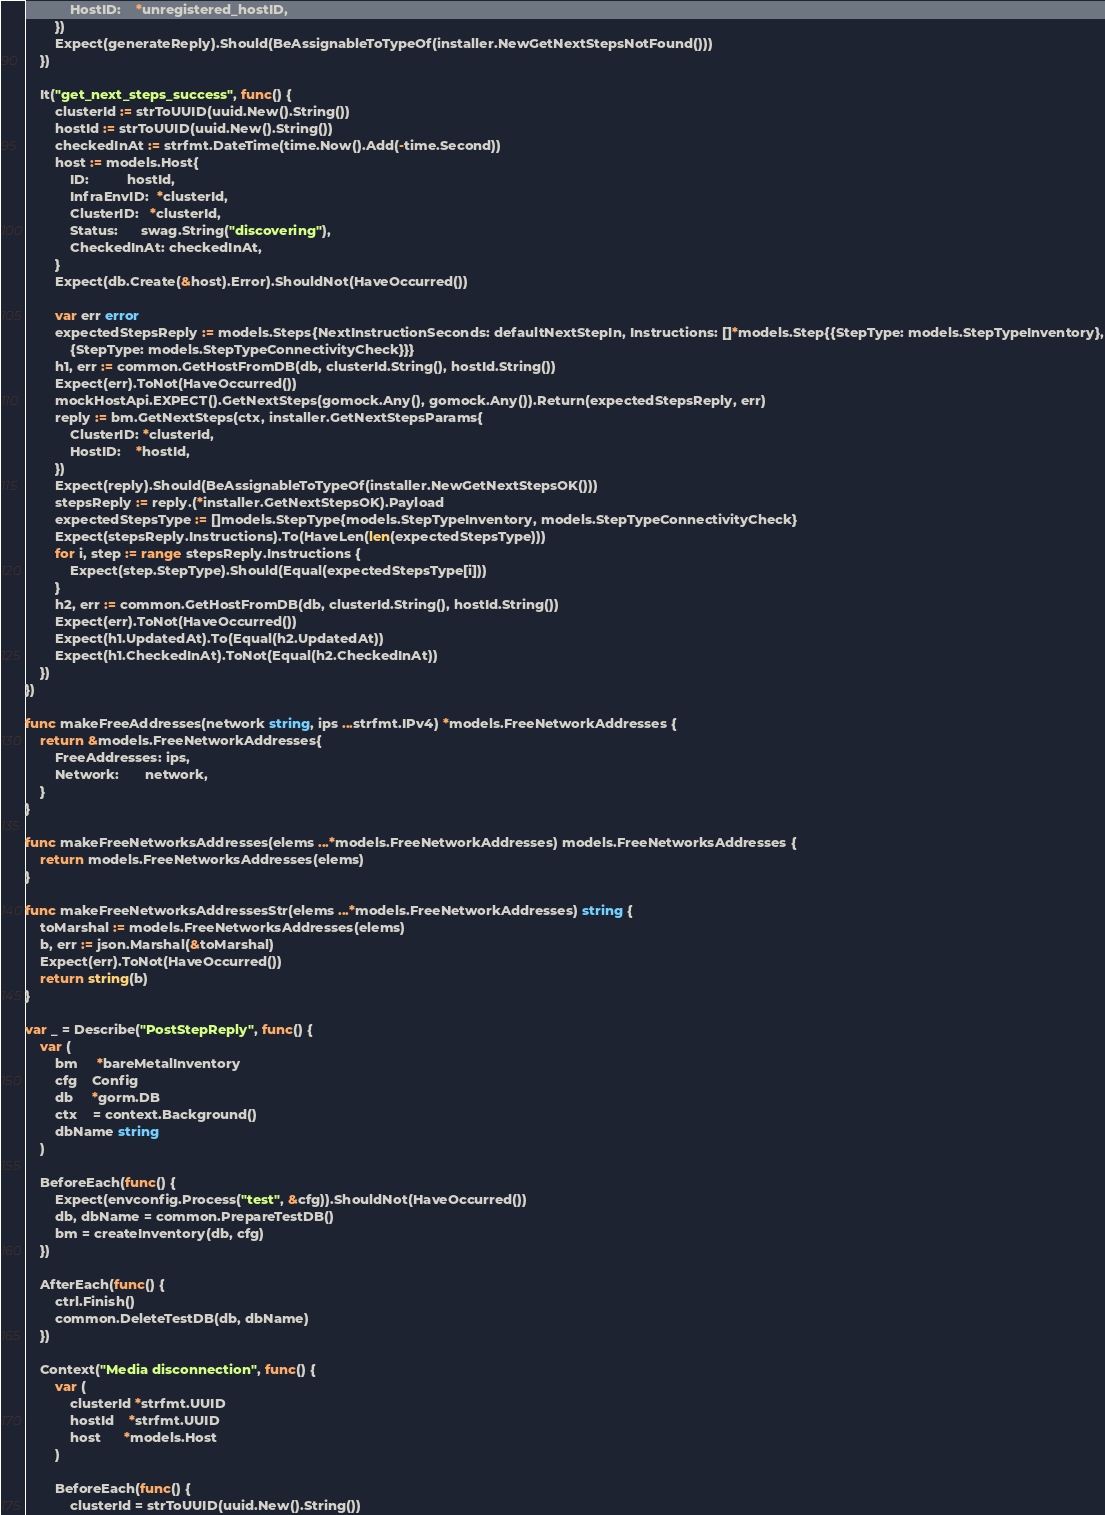<code> <loc_0><loc_0><loc_500><loc_500><_Go_>			HostID:    *unregistered_hostID,
		})
		Expect(generateReply).Should(BeAssignableToTypeOf(installer.NewGetNextStepsNotFound()))
	})

	It("get_next_steps_success", func() {
		clusterId := strToUUID(uuid.New().String())
		hostId := strToUUID(uuid.New().String())
		checkedInAt := strfmt.DateTime(time.Now().Add(-time.Second))
		host := models.Host{
			ID:          hostId,
			InfraEnvID:  *clusterId,
			ClusterID:   *clusterId,
			Status:      swag.String("discovering"),
			CheckedInAt: checkedInAt,
		}
		Expect(db.Create(&host).Error).ShouldNot(HaveOccurred())

		var err error
		expectedStepsReply := models.Steps{NextInstructionSeconds: defaultNextStepIn, Instructions: []*models.Step{{StepType: models.StepTypeInventory},
			{StepType: models.StepTypeConnectivityCheck}}}
		h1, err := common.GetHostFromDB(db, clusterId.String(), hostId.String())
		Expect(err).ToNot(HaveOccurred())
		mockHostApi.EXPECT().GetNextSteps(gomock.Any(), gomock.Any()).Return(expectedStepsReply, err)
		reply := bm.GetNextSteps(ctx, installer.GetNextStepsParams{
			ClusterID: *clusterId,
			HostID:    *hostId,
		})
		Expect(reply).Should(BeAssignableToTypeOf(installer.NewGetNextStepsOK()))
		stepsReply := reply.(*installer.GetNextStepsOK).Payload
		expectedStepsType := []models.StepType{models.StepTypeInventory, models.StepTypeConnectivityCheck}
		Expect(stepsReply.Instructions).To(HaveLen(len(expectedStepsType)))
		for i, step := range stepsReply.Instructions {
			Expect(step.StepType).Should(Equal(expectedStepsType[i]))
		}
		h2, err := common.GetHostFromDB(db, clusterId.String(), hostId.String())
		Expect(err).ToNot(HaveOccurred())
		Expect(h1.UpdatedAt).To(Equal(h2.UpdatedAt))
		Expect(h1.CheckedInAt).ToNot(Equal(h2.CheckedInAt))
	})
})

func makeFreeAddresses(network string, ips ...strfmt.IPv4) *models.FreeNetworkAddresses {
	return &models.FreeNetworkAddresses{
		FreeAddresses: ips,
		Network:       network,
	}
}

func makeFreeNetworksAddresses(elems ...*models.FreeNetworkAddresses) models.FreeNetworksAddresses {
	return models.FreeNetworksAddresses(elems)
}

func makeFreeNetworksAddressesStr(elems ...*models.FreeNetworkAddresses) string {
	toMarshal := models.FreeNetworksAddresses(elems)
	b, err := json.Marshal(&toMarshal)
	Expect(err).ToNot(HaveOccurred())
	return string(b)
}

var _ = Describe("PostStepReply", func() {
	var (
		bm     *bareMetalInventory
		cfg    Config
		db     *gorm.DB
		ctx    = context.Background()
		dbName string
	)

	BeforeEach(func() {
		Expect(envconfig.Process("test", &cfg)).ShouldNot(HaveOccurred())
		db, dbName = common.PrepareTestDB()
		bm = createInventory(db, cfg)
	})

	AfterEach(func() {
		ctrl.Finish()
		common.DeleteTestDB(db, dbName)
	})

	Context("Media disconnection", func() {
		var (
			clusterId *strfmt.UUID
			hostId    *strfmt.UUID
			host      *models.Host
		)

		BeforeEach(func() {
			clusterId = strToUUID(uuid.New().String())</code> 